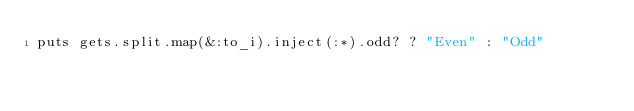Convert code to text. <code><loc_0><loc_0><loc_500><loc_500><_Ruby_>puts gets.split.map(&:to_i).inject(:*).odd? ? "Even" : "Odd"</code> 